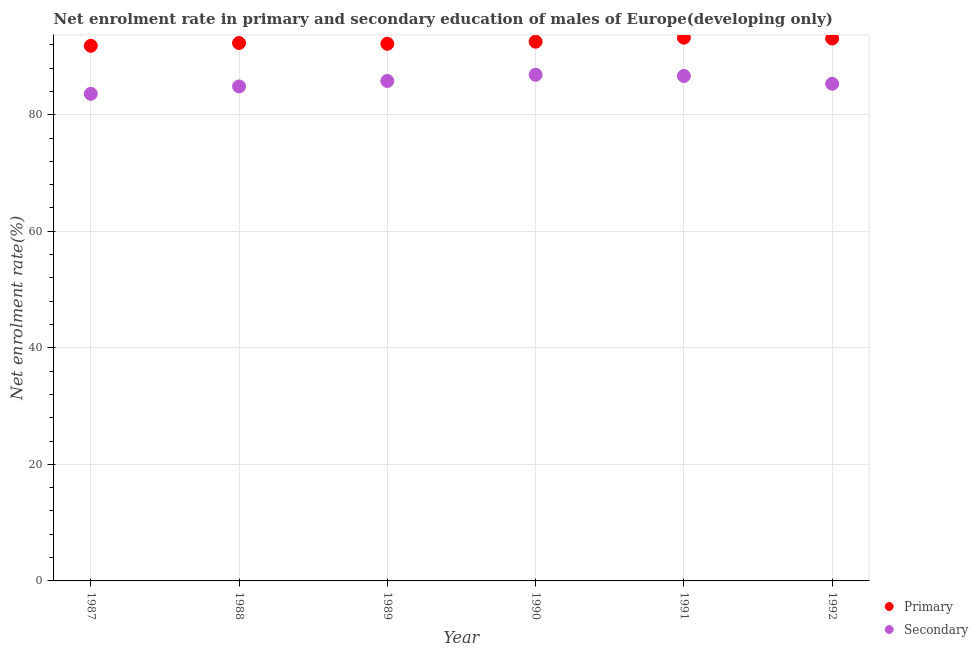How many different coloured dotlines are there?
Give a very brief answer. 2. What is the enrollment rate in secondary education in 1987?
Your answer should be very brief. 83.59. Across all years, what is the maximum enrollment rate in primary education?
Ensure brevity in your answer.  93.23. Across all years, what is the minimum enrollment rate in primary education?
Your answer should be compact. 91.83. In which year was the enrollment rate in primary education maximum?
Ensure brevity in your answer.  1991. In which year was the enrollment rate in primary education minimum?
Your response must be concise. 1987. What is the total enrollment rate in primary education in the graph?
Your answer should be compact. 555.16. What is the difference between the enrollment rate in secondary education in 1987 and that in 1989?
Provide a short and direct response. -2.2. What is the difference between the enrollment rate in primary education in 1987 and the enrollment rate in secondary education in 1991?
Ensure brevity in your answer.  5.17. What is the average enrollment rate in primary education per year?
Give a very brief answer. 92.53. In the year 1990, what is the difference between the enrollment rate in secondary education and enrollment rate in primary education?
Keep it short and to the point. -5.68. In how many years, is the enrollment rate in primary education greater than 12 %?
Give a very brief answer. 6. What is the ratio of the enrollment rate in primary education in 1987 to that in 1988?
Make the answer very short. 0.99. Is the difference between the enrollment rate in primary education in 1989 and 1992 greater than the difference between the enrollment rate in secondary education in 1989 and 1992?
Your response must be concise. No. What is the difference between the highest and the second highest enrollment rate in primary education?
Provide a short and direct response. 0.14. What is the difference between the highest and the lowest enrollment rate in secondary education?
Your answer should be compact. 3.26. In how many years, is the enrollment rate in primary education greater than the average enrollment rate in primary education taken over all years?
Your response must be concise. 3. Is the sum of the enrollment rate in primary education in 1990 and 1992 greater than the maximum enrollment rate in secondary education across all years?
Your answer should be compact. Yes. Does the enrollment rate in secondary education monotonically increase over the years?
Make the answer very short. No. How many dotlines are there?
Provide a short and direct response. 2. How many years are there in the graph?
Give a very brief answer. 6. Are the values on the major ticks of Y-axis written in scientific E-notation?
Provide a succinct answer. No. Does the graph contain grids?
Give a very brief answer. Yes. Where does the legend appear in the graph?
Offer a very short reply. Bottom right. How many legend labels are there?
Your response must be concise. 2. How are the legend labels stacked?
Make the answer very short. Vertical. What is the title of the graph?
Offer a very short reply. Net enrolment rate in primary and secondary education of males of Europe(developing only). Does "Register a property" appear as one of the legend labels in the graph?
Offer a terse response. No. What is the label or title of the X-axis?
Your answer should be very brief. Year. What is the label or title of the Y-axis?
Give a very brief answer. Net enrolment rate(%). What is the Net enrolment rate(%) of Primary in 1987?
Your response must be concise. 91.83. What is the Net enrolment rate(%) of Secondary in 1987?
Keep it short and to the point. 83.59. What is the Net enrolment rate(%) in Primary in 1988?
Ensure brevity in your answer.  92.31. What is the Net enrolment rate(%) of Secondary in 1988?
Provide a succinct answer. 84.86. What is the Net enrolment rate(%) of Primary in 1989?
Your answer should be very brief. 92.18. What is the Net enrolment rate(%) of Secondary in 1989?
Your response must be concise. 85.79. What is the Net enrolment rate(%) of Primary in 1990?
Your response must be concise. 92.54. What is the Net enrolment rate(%) in Secondary in 1990?
Offer a terse response. 86.86. What is the Net enrolment rate(%) in Primary in 1991?
Your answer should be very brief. 93.23. What is the Net enrolment rate(%) of Secondary in 1991?
Make the answer very short. 86.66. What is the Net enrolment rate(%) of Primary in 1992?
Your answer should be compact. 93.08. What is the Net enrolment rate(%) in Secondary in 1992?
Give a very brief answer. 85.31. Across all years, what is the maximum Net enrolment rate(%) in Primary?
Offer a very short reply. 93.23. Across all years, what is the maximum Net enrolment rate(%) of Secondary?
Your response must be concise. 86.86. Across all years, what is the minimum Net enrolment rate(%) in Primary?
Offer a very short reply. 91.83. Across all years, what is the minimum Net enrolment rate(%) in Secondary?
Make the answer very short. 83.59. What is the total Net enrolment rate(%) in Primary in the graph?
Offer a terse response. 555.16. What is the total Net enrolment rate(%) in Secondary in the graph?
Offer a terse response. 513.07. What is the difference between the Net enrolment rate(%) in Primary in 1987 and that in 1988?
Offer a very short reply. -0.48. What is the difference between the Net enrolment rate(%) of Secondary in 1987 and that in 1988?
Provide a succinct answer. -1.26. What is the difference between the Net enrolment rate(%) in Primary in 1987 and that in 1989?
Make the answer very short. -0.35. What is the difference between the Net enrolment rate(%) of Secondary in 1987 and that in 1989?
Your answer should be very brief. -2.2. What is the difference between the Net enrolment rate(%) of Primary in 1987 and that in 1990?
Your answer should be very brief. -0.71. What is the difference between the Net enrolment rate(%) of Secondary in 1987 and that in 1990?
Give a very brief answer. -3.26. What is the difference between the Net enrolment rate(%) of Primary in 1987 and that in 1991?
Provide a short and direct response. -1.39. What is the difference between the Net enrolment rate(%) in Secondary in 1987 and that in 1991?
Offer a very short reply. -3.07. What is the difference between the Net enrolment rate(%) in Primary in 1987 and that in 1992?
Your answer should be compact. -1.25. What is the difference between the Net enrolment rate(%) of Secondary in 1987 and that in 1992?
Make the answer very short. -1.72. What is the difference between the Net enrolment rate(%) of Primary in 1988 and that in 1989?
Offer a terse response. 0.13. What is the difference between the Net enrolment rate(%) of Secondary in 1988 and that in 1989?
Provide a succinct answer. -0.94. What is the difference between the Net enrolment rate(%) in Primary in 1988 and that in 1990?
Provide a succinct answer. -0.23. What is the difference between the Net enrolment rate(%) of Secondary in 1988 and that in 1990?
Your response must be concise. -2. What is the difference between the Net enrolment rate(%) of Primary in 1988 and that in 1991?
Ensure brevity in your answer.  -0.92. What is the difference between the Net enrolment rate(%) of Secondary in 1988 and that in 1991?
Your response must be concise. -1.8. What is the difference between the Net enrolment rate(%) in Primary in 1988 and that in 1992?
Your response must be concise. -0.78. What is the difference between the Net enrolment rate(%) in Secondary in 1988 and that in 1992?
Your answer should be compact. -0.46. What is the difference between the Net enrolment rate(%) in Primary in 1989 and that in 1990?
Provide a short and direct response. -0.36. What is the difference between the Net enrolment rate(%) of Secondary in 1989 and that in 1990?
Your answer should be compact. -1.06. What is the difference between the Net enrolment rate(%) of Primary in 1989 and that in 1991?
Your answer should be very brief. -1.05. What is the difference between the Net enrolment rate(%) of Secondary in 1989 and that in 1991?
Offer a terse response. -0.86. What is the difference between the Net enrolment rate(%) of Primary in 1989 and that in 1992?
Provide a succinct answer. -0.91. What is the difference between the Net enrolment rate(%) of Secondary in 1989 and that in 1992?
Provide a succinct answer. 0.48. What is the difference between the Net enrolment rate(%) in Primary in 1990 and that in 1991?
Provide a succinct answer. -0.69. What is the difference between the Net enrolment rate(%) of Secondary in 1990 and that in 1991?
Your answer should be very brief. 0.2. What is the difference between the Net enrolment rate(%) of Primary in 1990 and that in 1992?
Keep it short and to the point. -0.55. What is the difference between the Net enrolment rate(%) in Secondary in 1990 and that in 1992?
Your answer should be compact. 1.54. What is the difference between the Net enrolment rate(%) in Primary in 1991 and that in 1992?
Your answer should be compact. 0.14. What is the difference between the Net enrolment rate(%) of Secondary in 1991 and that in 1992?
Ensure brevity in your answer.  1.35. What is the difference between the Net enrolment rate(%) in Primary in 1987 and the Net enrolment rate(%) in Secondary in 1988?
Ensure brevity in your answer.  6.97. What is the difference between the Net enrolment rate(%) of Primary in 1987 and the Net enrolment rate(%) of Secondary in 1989?
Offer a terse response. 6.04. What is the difference between the Net enrolment rate(%) of Primary in 1987 and the Net enrolment rate(%) of Secondary in 1990?
Offer a very short reply. 4.97. What is the difference between the Net enrolment rate(%) in Primary in 1987 and the Net enrolment rate(%) in Secondary in 1991?
Ensure brevity in your answer.  5.17. What is the difference between the Net enrolment rate(%) of Primary in 1987 and the Net enrolment rate(%) of Secondary in 1992?
Your answer should be very brief. 6.52. What is the difference between the Net enrolment rate(%) in Primary in 1988 and the Net enrolment rate(%) in Secondary in 1989?
Ensure brevity in your answer.  6.51. What is the difference between the Net enrolment rate(%) of Primary in 1988 and the Net enrolment rate(%) of Secondary in 1990?
Give a very brief answer. 5.45. What is the difference between the Net enrolment rate(%) in Primary in 1988 and the Net enrolment rate(%) in Secondary in 1991?
Offer a terse response. 5.65. What is the difference between the Net enrolment rate(%) in Primary in 1988 and the Net enrolment rate(%) in Secondary in 1992?
Ensure brevity in your answer.  6.99. What is the difference between the Net enrolment rate(%) in Primary in 1989 and the Net enrolment rate(%) in Secondary in 1990?
Your answer should be very brief. 5.32. What is the difference between the Net enrolment rate(%) of Primary in 1989 and the Net enrolment rate(%) of Secondary in 1991?
Offer a very short reply. 5.52. What is the difference between the Net enrolment rate(%) in Primary in 1989 and the Net enrolment rate(%) in Secondary in 1992?
Make the answer very short. 6.87. What is the difference between the Net enrolment rate(%) of Primary in 1990 and the Net enrolment rate(%) of Secondary in 1991?
Give a very brief answer. 5.88. What is the difference between the Net enrolment rate(%) of Primary in 1990 and the Net enrolment rate(%) of Secondary in 1992?
Your answer should be compact. 7.23. What is the difference between the Net enrolment rate(%) in Primary in 1991 and the Net enrolment rate(%) in Secondary in 1992?
Provide a succinct answer. 7.91. What is the average Net enrolment rate(%) in Primary per year?
Keep it short and to the point. 92.53. What is the average Net enrolment rate(%) of Secondary per year?
Give a very brief answer. 85.51. In the year 1987, what is the difference between the Net enrolment rate(%) of Primary and Net enrolment rate(%) of Secondary?
Your response must be concise. 8.24. In the year 1988, what is the difference between the Net enrolment rate(%) of Primary and Net enrolment rate(%) of Secondary?
Offer a terse response. 7.45. In the year 1989, what is the difference between the Net enrolment rate(%) of Primary and Net enrolment rate(%) of Secondary?
Ensure brevity in your answer.  6.38. In the year 1990, what is the difference between the Net enrolment rate(%) in Primary and Net enrolment rate(%) in Secondary?
Provide a succinct answer. 5.68. In the year 1991, what is the difference between the Net enrolment rate(%) of Primary and Net enrolment rate(%) of Secondary?
Offer a very short reply. 6.57. In the year 1992, what is the difference between the Net enrolment rate(%) of Primary and Net enrolment rate(%) of Secondary?
Offer a very short reply. 7.77. What is the ratio of the Net enrolment rate(%) in Secondary in 1987 to that in 1988?
Keep it short and to the point. 0.99. What is the ratio of the Net enrolment rate(%) in Secondary in 1987 to that in 1989?
Offer a very short reply. 0.97. What is the ratio of the Net enrolment rate(%) of Secondary in 1987 to that in 1990?
Make the answer very short. 0.96. What is the ratio of the Net enrolment rate(%) in Primary in 1987 to that in 1991?
Make the answer very short. 0.98. What is the ratio of the Net enrolment rate(%) in Secondary in 1987 to that in 1991?
Your response must be concise. 0.96. What is the ratio of the Net enrolment rate(%) in Primary in 1987 to that in 1992?
Your response must be concise. 0.99. What is the ratio of the Net enrolment rate(%) in Secondary in 1987 to that in 1992?
Your response must be concise. 0.98. What is the ratio of the Net enrolment rate(%) in Secondary in 1988 to that in 1989?
Give a very brief answer. 0.99. What is the ratio of the Net enrolment rate(%) in Primary in 1988 to that in 1991?
Offer a very short reply. 0.99. What is the ratio of the Net enrolment rate(%) in Secondary in 1988 to that in 1991?
Ensure brevity in your answer.  0.98. What is the ratio of the Net enrolment rate(%) of Primary in 1988 to that in 1992?
Offer a terse response. 0.99. What is the ratio of the Net enrolment rate(%) of Secondary in 1988 to that in 1992?
Provide a short and direct response. 0.99. What is the ratio of the Net enrolment rate(%) of Secondary in 1989 to that in 1990?
Provide a succinct answer. 0.99. What is the ratio of the Net enrolment rate(%) in Primary in 1989 to that in 1992?
Make the answer very short. 0.99. What is the ratio of the Net enrolment rate(%) in Secondary in 1989 to that in 1992?
Make the answer very short. 1.01. What is the ratio of the Net enrolment rate(%) of Secondary in 1990 to that in 1991?
Ensure brevity in your answer.  1. What is the ratio of the Net enrolment rate(%) of Primary in 1990 to that in 1992?
Your answer should be very brief. 0.99. What is the ratio of the Net enrolment rate(%) in Secondary in 1990 to that in 1992?
Your answer should be compact. 1.02. What is the ratio of the Net enrolment rate(%) of Primary in 1991 to that in 1992?
Your answer should be very brief. 1. What is the ratio of the Net enrolment rate(%) in Secondary in 1991 to that in 1992?
Your answer should be compact. 1.02. What is the difference between the highest and the second highest Net enrolment rate(%) of Primary?
Give a very brief answer. 0.14. What is the difference between the highest and the second highest Net enrolment rate(%) in Secondary?
Provide a short and direct response. 0.2. What is the difference between the highest and the lowest Net enrolment rate(%) in Primary?
Make the answer very short. 1.39. What is the difference between the highest and the lowest Net enrolment rate(%) in Secondary?
Offer a terse response. 3.26. 